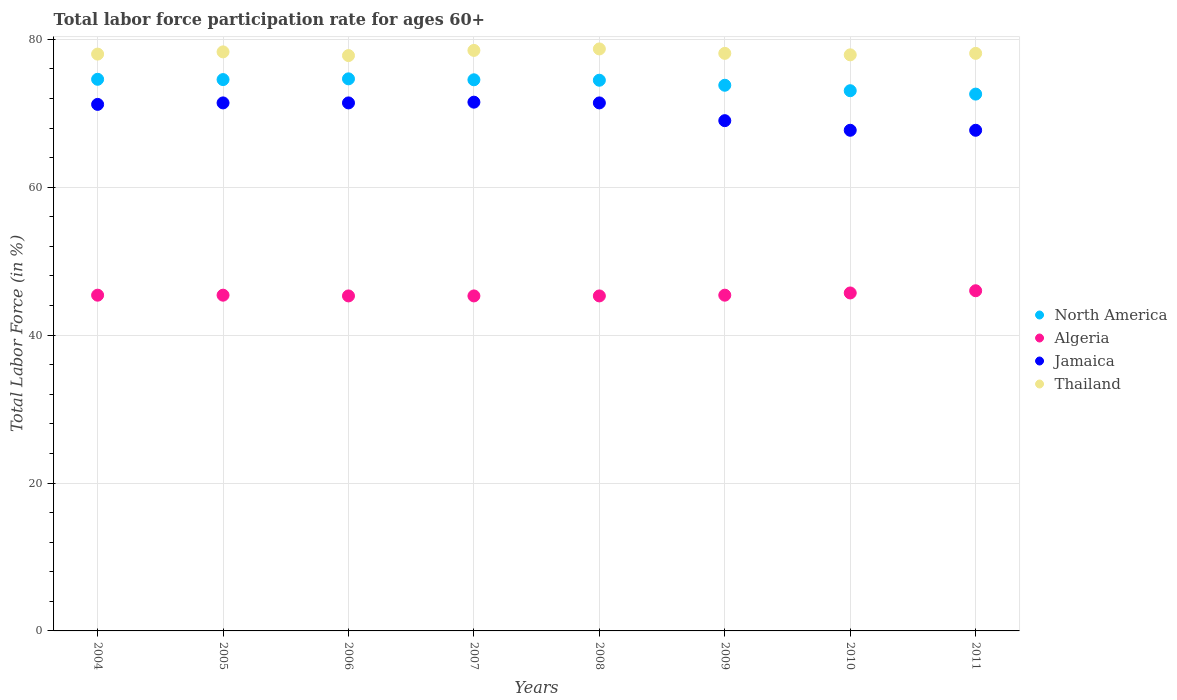What is the labor force participation rate in Algeria in 2006?
Your answer should be compact. 45.3. Across all years, what is the maximum labor force participation rate in North America?
Provide a short and direct response. 74.65. Across all years, what is the minimum labor force participation rate in Algeria?
Ensure brevity in your answer.  45.3. In which year was the labor force participation rate in North America maximum?
Provide a succinct answer. 2006. What is the total labor force participation rate in Algeria in the graph?
Ensure brevity in your answer.  363.8. What is the difference between the labor force participation rate in Thailand in 2010 and that in 2011?
Offer a terse response. -0.2. What is the difference between the labor force participation rate in Thailand in 2006 and the labor force participation rate in Algeria in 2008?
Give a very brief answer. 32.5. What is the average labor force participation rate in North America per year?
Make the answer very short. 74.03. In the year 2005, what is the difference between the labor force participation rate in North America and labor force participation rate in Thailand?
Keep it short and to the point. -3.75. In how many years, is the labor force participation rate in North America greater than 28 %?
Ensure brevity in your answer.  8. What is the ratio of the labor force participation rate in North America in 2004 to that in 2010?
Your answer should be very brief. 1.02. Is the difference between the labor force participation rate in North America in 2004 and 2010 greater than the difference between the labor force participation rate in Thailand in 2004 and 2010?
Offer a very short reply. Yes. What is the difference between the highest and the second highest labor force participation rate in North America?
Provide a short and direct response. 0.06. What is the difference between the highest and the lowest labor force participation rate in Algeria?
Provide a succinct answer. 0.7. Does the labor force participation rate in North America monotonically increase over the years?
Your response must be concise. No. Is the labor force participation rate in Jamaica strictly greater than the labor force participation rate in Algeria over the years?
Make the answer very short. Yes. How many dotlines are there?
Ensure brevity in your answer.  4. Are the values on the major ticks of Y-axis written in scientific E-notation?
Keep it short and to the point. No. What is the title of the graph?
Keep it short and to the point. Total labor force participation rate for ages 60+. Does "Germany" appear as one of the legend labels in the graph?
Offer a terse response. No. What is the Total Labor Force (in %) in North America in 2004?
Provide a short and direct response. 74.59. What is the Total Labor Force (in %) of Algeria in 2004?
Your answer should be compact. 45.4. What is the Total Labor Force (in %) of Jamaica in 2004?
Offer a very short reply. 71.2. What is the Total Labor Force (in %) in Thailand in 2004?
Ensure brevity in your answer.  78. What is the Total Labor Force (in %) in North America in 2005?
Offer a very short reply. 74.55. What is the Total Labor Force (in %) of Algeria in 2005?
Give a very brief answer. 45.4. What is the Total Labor Force (in %) of Jamaica in 2005?
Ensure brevity in your answer.  71.4. What is the Total Labor Force (in %) of Thailand in 2005?
Offer a terse response. 78.3. What is the Total Labor Force (in %) in North America in 2006?
Provide a succinct answer. 74.65. What is the Total Labor Force (in %) in Algeria in 2006?
Offer a very short reply. 45.3. What is the Total Labor Force (in %) in Jamaica in 2006?
Keep it short and to the point. 71.4. What is the Total Labor Force (in %) of Thailand in 2006?
Your answer should be compact. 77.8. What is the Total Labor Force (in %) of North America in 2007?
Provide a succinct answer. 74.53. What is the Total Labor Force (in %) in Algeria in 2007?
Provide a short and direct response. 45.3. What is the Total Labor Force (in %) in Jamaica in 2007?
Your answer should be compact. 71.5. What is the Total Labor Force (in %) of Thailand in 2007?
Keep it short and to the point. 78.5. What is the Total Labor Force (in %) of North America in 2008?
Give a very brief answer. 74.47. What is the Total Labor Force (in %) of Algeria in 2008?
Your response must be concise. 45.3. What is the Total Labor Force (in %) of Jamaica in 2008?
Make the answer very short. 71.4. What is the Total Labor Force (in %) of Thailand in 2008?
Provide a short and direct response. 78.7. What is the Total Labor Force (in %) in North America in 2009?
Ensure brevity in your answer.  73.79. What is the Total Labor Force (in %) of Algeria in 2009?
Provide a short and direct response. 45.4. What is the Total Labor Force (in %) in Thailand in 2009?
Keep it short and to the point. 78.1. What is the Total Labor Force (in %) in North America in 2010?
Your answer should be very brief. 73.05. What is the Total Labor Force (in %) of Algeria in 2010?
Offer a terse response. 45.7. What is the Total Labor Force (in %) of Jamaica in 2010?
Offer a very short reply. 67.7. What is the Total Labor Force (in %) in Thailand in 2010?
Ensure brevity in your answer.  77.9. What is the Total Labor Force (in %) of North America in 2011?
Keep it short and to the point. 72.59. What is the Total Labor Force (in %) in Jamaica in 2011?
Your response must be concise. 67.7. What is the Total Labor Force (in %) of Thailand in 2011?
Your answer should be very brief. 78.1. Across all years, what is the maximum Total Labor Force (in %) of North America?
Provide a short and direct response. 74.65. Across all years, what is the maximum Total Labor Force (in %) of Algeria?
Make the answer very short. 46. Across all years, what is the maximum Total Labor Force (in %) of Jamaica?
Keep it short and to the point. 71.5. Across all years, what is the maximum Total Labor Force (in %) in Thailand?
Your response must be concise. 78.7. Across all years, what is the minimum Total Labor Force (in %) of North America?
Keep it short and to the point. 72.59. Across all years, what is the minimum Total Labor Force (in %) in Algeria?
Give a very brief answer. 45.3. Across all years, what is the minimum Total Labor Force (in %) of Jamaica?
Offer a terse response. 67.7. Across all years, what is the minimum Total Labor Force (in %) in Thailand?
Offer a terse response. 77.8. What is the total Total Labor Force (in %) of North America in the graph?
Make the answer very short. 592.22. What is the total Total Labor Force (in %) in Algeria in the graph?
Give a very brief answer. 363.8. What is the total Total Labor Force (in %) of Jamaica in the graph?
Offer a terse response. 561.3. What is the total Total Labor Force (in %) of Thailand in the graph?
Give a very brief answer. 625.4. What is the difference between the Total Labor Force (in %) in North America in 2004 and that in 2005?
Offer a very short reply. 0.04. What is the difference between the Total Labor Force (in %) in Jamaica in 2004 and that in 2005?
Your response must be concise. -0.2. What is the difference between the Total Labor Force (in %) in North America in 2004 and that in 2006?
Provide a succinct answer. -0.06. What is the difference between the Total Labor Force (in %) in Thailand in 2004 and that in 2006?
Ensure brevity in your answer.  0.2. What is the difference between the Total Labor Force (in %) of North America in 2004 and that in 2007?
Ensure brevity in your answer.  0.07. What is the difference between the Total Labor Force (in %) of Algeria in 2004 and that in 2007?
Give a very brief answer. 0.1. What is the difference between the Total Labor Force (in %) of Jamaica in 2004 and that in 2007?
Your answer should be very brief. -0.3. What is the difference between the Total Labor Force (in %) in Thailand in 2004 and that in 2007?
Provide a short and direct response. -0.5. What is the difference between the Total Labor Force (in %) of North America in 2004 and that in 2008?
Keep it short and to the point. 0.13. What is the difference between the Total Labor Force (in %) in Jamaica in 2004 and that in 2008?
Offer a very short reply. -0.2. What is the difference between the Total Labor Force (in %) of Thailand in 2004 and that in 2008?
Your answer should be compact. -0.7. What is the difference between the Total Labor Force (in %) in North America in 2004 and that in 2009?
Offer a very short reply. 0.81. What is the difference between the Total Labor Force (in %) of North America in 2004 and that in 2010?
Offer a terse response. 1.54. What is the difference between the Total Labor Force (in %) in North America in 2004 and that in 2011?
Ensure brevity in your answer.  2. What is the difference between the Total Labor Force (in %) in Thailand in 2004 and that in 2011?
Your answer should be very brief. -0.1. What is the difference between the Total Labor Force (in %) in North America in 2005 and that in 2006?
Ensure brevity in your answer.  -0.1. What is the difference between the Total Labor Force (in %) in Jamaica in 2005 and that in 2006?
Give a very brief answer. 0. What is the difference between the Total Labor Force (in %) of Thailand in 2005 and that in 2006?
Offer a terse response. 0.5. What is the difference between the Total Labor Force (in %) of North America in 2005 and that in 2007?
Provide a short and direct response. 0.03. What is the difference between the Total Labor Force (in %) in North America in 2005 and that in 2008?
Make the answer very short. 0.09. What is the difference between the Total Labor Force (in %) in Algeria in 2005 and that in 2008?
Provide a short and direct response. 0.1. What is the difference between the Total Labor Force (in %) of North America in 2005 and that in 2009?
Provide a short and direct response. 0.77. What is the difference between the Total Labor Force (in %) of Algeria in 2005 and that in 2009?
Ensure brevity in your answer.  0. What is the difference between the Total Labor Force (in %) of Jamaica in 2005 and that in 2009?
Provide a short and direct response. 2.4. What is the difference between the Total Labor Force (in %) of North America in 2005 and that in 2010?
Offer a terse response. 1.5. What is the difference between the Total Labor Force (in %) in Jamaica in 2005 and that in 2010?
Make the answer very short. 3.7. What is the difference between the Total Labor Force (in %) in Thailand in 2005 and that in 2010?
Ensure brevity in your answer.  0.4. What is the difference between the Total Labor Force (in %) in North America in 2005 and that in 2011?
Give a very brief answer. 1.96. What is the difference between the Total Labor Force (in %) in Thailand in 2005 and that in 2011?
Your answer should be compact. 0.2. What is the difference between the Total Labor Force (in %) in North America in 2006 and that in 2007?
Your response must be concise. 0.13. What is the difference between the Total Labor Force (in %) of Algeria in 2006 and that in 2007?
Offer a very short reply. 0. What is the difference between the Total Labor Force (in %) of North America in 2006 and that in 2008?
Give a very brief answer. 0.19. What is the difference between the Total Labor Force (in %) of Algeria in 2006 and that in 2008?
Ensure brevity in your answer.  0. What is the difference between the Total Labor Force (in %) in Jamaica in 2006 and that in 2008?
Your answer should be compact. 0. What is the difference between the Total Labor Force (in %) in Thailand in 2006 and that in 2008?
Your answer should be very brief. -0.9. What is the difference between the Total Labor Force (in %) of North America in 2006 and that in 2009?
Ensure brevity in your answer.  0.87. What is the difference between the Total Labor Force (in %) of Thailand in 2006 and that in 2009?
Offer a terse response. -0.3. What is the difference between the Total Labor Force (in %) in North America in 2006 and that in 2010?
Offer a very short reply. 1.6. What is the difference between the Total Labor Force (in %) in Algeria in 2006 and that in 2010?
Your answer should be compact. -0.4. What is the difference between the Total Labor Force (in %) in Thailand in 2006 and that in 2010?
Your answer should be compact. -0.1. What is the difference between the Total Labor Force (in %) of North America in 2006 and that in 2011?
Offer a very short reply. 2.06. What is the difference between the Total Labor Force (in %) of Algeria in 2006 and that in 2011?
Make the answer very short. -0.7. What is the difference between the Total Labor Force (in %) in Jamaica in 2006 and that in 2011?
Offer a very short reply. 3.7. What is the difference between the Total Labor Force (in %) of North America in 2007 and that in 2008?
Your response must be concise. 0.06. What is the difference between the Total Labor Force (in %) in Thailand in 2007 and that in 2008?
Keep it short and to the point. -0.2. What is the difference between the Total Labor Force (in %) of North America in 2007 and that in 2009?
Make the answer very short. 0.74. What is the difference between the Total Labor Force (in %) in Algeria in 2007 and that in 2009?
Ensure brevity in your answer.  -0.1. What is the difference between the Total Labor Force (in %) in Thailand in 2007 and that in 2009?
Your answer should be very brief. 0.4. What is the difference between the Total Labor Force (in %) in North America in 2007 and that in 2010?
Offer a very short reply. 1.48. What is the difference between the Total Labor Force (in %) in Jamaica in 2007 and that in 2010?
Make the answer very short. 3.8. What is the difference between the Total Labor Force (in %) in Thailand in 2007 and that in 2010?
Give a very brief answer. 0.6. What is the difference between the Total Labor Force (in %) of North America in 2007 and that in 2011?
Your answer should be compact. 1.93. What is the difference between the Total Labor Force (in %) of Algeria in 2007 and that in 2011?
Ensure brevity in your answer.  -0.7. What is the difference between the Total Labor Force (in %) of Jamaica in 2007 and that in 2011?
Keep it short and to the point. 3.8. What is the difference between the Total Labor Force (in %) of North America in 2008 and that in 2009?
Your answer should be very brief. 0.68. What is the difference between the Total Labor Force (in %) in Algeria in 2008 and that in 2009?
Provide a short and direct response. -0.1. What is the difference between the Total Labor Force (in %) of Jamaica in 2008 and that in 2009?
Provide a short and direct response. 2.4. What is the difference between the Total Labor Force (in %) in Thailand in 2008 and that in 2009?
Your answer should be compact. 0.6. What is the difference between the Total Labor Force (in %) of North America in 2008 and that in 2010?
Your response must be concise. 1.42. What is the difference between the Total Labor Force (in %) in Jamaica in 2008 and that in 2010?
Offer a terse response. 3.7. What is the difference between the Total Labor Force (in %) of North America in 2008 and that in 2011?
Provide a succinct answer. 1.88. What is the difference between the Total Labor Force (in %) in Jamaica in 2008 and that in 2011?
Give a very brief answer. 3.7. What is the difference between the Total Labor Force (in %) in North America in 2009 and that in 2010?
Ensure brevity in your answer.  0.74. What is the difference between the Total Labor Force (in %) in Algeria in 2009 and that in 2010?
Make the answer very short. -0.3. What is the difference between the Total Labor Force (in %) of Thailand in 2009 and that in 2010?
Keep it short and to the point. 0.2. What is the difference between the Total Labor Force (in %) of North America in 2009 and that in 2011?
Provide a succinct answer. 1.2. What is the difference between the Total Labor Force (in %) of Jamaica in 2009 and that in 2011?
Make the answer very short. 1.3. What is the difference between the Total Labor Force (in %) of North America in 2010 and that in 2011?
Provide a succinct answer. 0.46. What is the difference between the Total Labor Force (in %) of Algeria in 2010 and that in 2011?
Your answer should be very brief. -0.3. What is the difference between the Total Labor Force (in %) of North America in 2004 and the Total Labor Force (in %) of Algeria in 2005?
Keep it short and to the point. 29.19. What is the difference between the Total Labor Force (in %) in North America in 2004 and the Total Labor Force (in %) in Jamaica in 2005?
Your answer should be compact. 3.19. What is the difference between the Total Labor Force (in %) in North America in 2004 and the Total Labor Force (in %) in Thailand in 2005?
Your answer should be compact. -3.71. What is the difference between the Total Labor Force (in %) of Algeria in 2004 and the Total Labor Force (in %) of Jamaica in 2005?
Provide a succinct answer. -26. What is the difference between the Total Labor Force (in %) of Algeria in 2004 and the Total Labor Force (in %) of Thailand in 2005?
Your answer should be compact. -32.9. What is the difference between the Total Labor Force (in %) in Jamaica in 2004 and the Total Labor Force (in %) in Thailand in 2005?
Give a very brief answer. -7.1. What is the difference between the Total Labor Force (in %) in North America in 2004 and the Total Labor Force (in %) in Algeria in 2006?
Your answer should be compact. 29.29. What is the difference between the Total Labor Force (in %) of North America in 2004 and the Total Labor Force (in %) of Jamaica in 2006?
Provide a succinct answer. 3.19. What is the difference between the Total Labor Force (in %) in North America in 2004 and the Total Labor Force (in %) in Thailand in 2006?
Ensure brevity in your answer.  -3.21. What is the difference between the Total Labor Force (in %) in Algeria in 2004 and the Total Labor Force (in %) in Jamaica in 2006?
Your answer should be very brief. -26. What is the difference between the Total Labor Force (in %) in Algeria in 2004 and the Total Labor Force (in %) in Thailand in 2006?
Provide a succinct answer. -32.4. What is the difference between the Total Labor Force (in %) in Jamaica in 2004 and the Total Labor Force (in %) in Thailand in 2006?
Your answer should be very brief. -6.6. What is the difference between the Total Labor Force (in %) of North America in 2004 and the Total Labor Force (in %) of Algeria in 2007?
Your answer should be compact. 29.29. What is the difference between the Total Labor Force (in %) in North America in 2004 and the Total Labor Force (in %) in Jamaica in 2007?
Provide a succinct answer. 3.09. What is the difference between the Total Labor Force (in %) in North America in 2004 and the Total Labor Force (in %) in Thailand in 2007?
Make the answer very short. -3.91. What is the difference between the Total Labor Force (in %) in Algeria in 2004 and the Total Labor Force (in %) in Jamaica in 2007?
Offer a terse response. -26.1. What is the difference between the Total Labor Force (in %) in Algeria in 2004 and the Total Labor Force (in %) in Thailand in 2007?
Your response must be concise. -33.1. What is the difference between the Total Labor Force (in %) of Jamaica in 2004 and the Total Labor Force (in %) of Thailand in 2007?
Your answer should be compact. -7.3. What is the difference between the Total Labor Force (in %) of North America in 2004 and the Total Labor Force (in %) of Algeria in 2008?
Offer a terse response. 29.29. What is the difference between the Total Labor Force (in %) in North America in 2004 and the Total Labor Force (in %) in Jamaica in 2008?
Your answer should be compact. 3.19. What is the difference between the Total Labor Force (in %) of North America in 2004 and the Total Labor Force (in %) of Thailand in 2008?
Your response must be concise. -4.11. What is the difference between the Total Labor Force (in %) in Algeria in 2004 and the Total Labor Force (in %) in Thailand in 2008?
Offer a terse response. -33.3. What is the difference between the Total Labor Force (in %) in Jamaica in 2004 and the Total Labor Force (in %) in Thailand in 2008?
Make the answer very short. -7.5. What is the difference between the Total Labor Force (in %) of North America in 2004 and the Total Labor Force (in %) of Algeria in 2009?
Give a very brief answer. 29.19. What is the difference between the Total Labor Force (in %) of North America in 2004 and the Total Labor Force (in %) of Jamaica in 2009?
Provide a succinct answer. 5.59. What is the difference between the Total Labor Force (in %) of North America in 2004 and the Total Labor Force (in %) of Thailand in 2009?
Offer a terse response. -3.51. What is the difference between the Total Labor Force (in %) of Algeria in 2004 and the Total Labor Force (in %) of Jamaica in 2009?
Keep it short and to the point. -23.6. What is the difference between the Total Labor Force (in %) of Algeria in 2004 and the Total Labor Force (in %) of Thailand in 2009?
Make the answer very short. -32.7. What is the difference between the Total Labor Force (in %) in North America in 2004 and the Total Labor Force (in %) in Algeria in 2010?
Offer a very short reply. 28.89. What is the difference between the Total Labor Force (in %) in North America in 2004 and the Total Labor Force (in %) in Jamaica in 2010?
Offer a very short reply. 6.89. What is the difference between the Total Labor Force (in %) in North America in 2004 and the Total Labor Force (in %) in Thailand in 2010?
Ensure brevity in your answer.  -3.31. What is the difference between the Total Labor Force (in %) of Algeria in 2004 and the Total Labor Force (in %) of Jamaica in 2010?
Ensure brevity in your answer.  -22.3. What is the difference between the Total Labor Force (in %) of Algeria in 2004 and the Total Labor Force (in %) of Thailand in 2010?
Offer a very short reply. -32.5. What is the difference between the Total Labor Force (in %) in Jamaica in 2004 and the Total Labor Force (in %) in Thailand in 2010?
Offer a very short reply. -6.7. What is the difference between the Total Labor Force (in %) of North America in 2004 and the Total Labor Force (in %) of Algeria in 2011?
Give a very brief answer. 28.59. What is the difference between the Total Labor Force (in %) in North America in 2004 and the Total Labor Force (in %) in Jamaica in 2011?
Your answer should be compact. 6.89. What is the difference between the Total Labor Force (in %) in North America in 2004 and the Total Labor Force (in %) in Thailand in 2011?
Provide a short and direct response. -3.51. What is the difference between the Total Labor Force (in %) of Algeria in 2004 and the Total Labor Force (in %) of Jamaica in 2011?
Your answer should be compact. -22.3. What is the difference between the Total Labor Force (in %) in Algeria in 2004 and the Total Labor Force (in %) in Thailand in 2011?
Keep it short and to the point. -32.7. What is the difference between the Total Labor Force (in %) in Jamaica in 2004 and the Total Labor Force (in %) in Thailand in 2011?
Keep it short and to the point. -6.9. What is the difference between the Total Labor Force (in %) in North America in 2005 and the Total Labor Force (in %) in Algeria in 2006?
Provide a short and direct response. 29.25. What is the difference between the Total Labor Force (in %) in North America in 2005 and the Total Labor Force (in %) in Jamaica in 2006?
Your response must be concise. 3.15. What is the difference between the Total Labor Force (in %) in North America in 2005 and the Total Labor Force (in %) in Thailand in 2006?
Make the answer very short. -3.25. What is the difference between the Total Labor Force (in %) in Algeria in 2005 and the Total Labor Force (in %) in Thailand in 2006?
Your answer should be very brief. -32.4. What is the difference between the Total Labor Force (in %) of North America in 2005 and the Total Labor Force (in %) of Algeria in 2007?
Offer a terse response. 29.25. What is the difference between the Total Labor Force (in %) of North America in 2005 and the Total Labor Force (in %) of Jamaica in 2007?
Your answer should be compact. 3.05. What is the difference between the Total Labor Force (in %) in North America in 2005 and the Total Labor Force (in %) in Thailand in 2007?
Offer a very short reply. -3.95. What is the difference between the Total Labor Force (in %) of Algeria in 2005 and the Total Labor Force (in %) of Jamaica in 2007?
Your answer should be compact. -26.1. What is the difference between the Total Labor Force (in %) in Algeria in 2005 and the Total Labor Force (in %) in Thailand in 2007?
Your answer should be very brief. -33.1. What is the difference between the Total Labor Force (in %) of Jamaica in 2005 and the Total Labor Force (in %) of Thailand in 2007?
Ensure brevity in your answer.  -7.1. What is the difference between the Total Labor Force (in %) in North America in 2005 and the Total Labor Force (in %) in Algeria in 2008?
Ensure brevity in your answer.  29.25. What is the difference between the Total Labor Force (in %) of North America in 2005 and the Total Labor Force (in %) of Jamaica in 2008?
Ensure brevity in your answer.  3.15. What is the difference between the Total Labor Force (in %) of North America in 2005 and the Total Labor Force (in %) of Thailand in 2008?
Offer a terse response. -4.15. What is the difference between the Total Labor Force (in %) in Algeria in 2005 and the Total Labor Force (in %) in Thailand in 2008?
Make the answer very short. -33.3. What is the difference between the Total Labor Force (in %) of Jamaica in 2005 and the Total Labor Force (in %) of Thailand in 2008?
Provide a short and direct response. -7.3. What is the difference between the Total Labor Force (in %) of North America in 2005 and the Total Labor Force (in %) of Algeria in 2009?
Provide a short and direct response. 29.15. What is the difference between the Total Labor Force (in %) of North America in 2005 and the Total Labor Force (in %) of Jamaica in 2009?
Give a very brief answer. 5.55. What is the difference between the Total Labor Force (in %) in North America in 2005 and the Total Labor Force (in %) in Thailand in 2009?
Your answer should be very brief. -3.55. What is the difference between the Total Labor Force (in %) of Algeria in 2005 and the Total Labor Force (in %) of Jamaica in 2009?
Ensure brevity in your answer.  -23.6. What is the difference between the Total Labor Force (in %) in Algeria in 2005 and the Total Labor Force (in %) in Thailand in 2009?
Provide a succinct answer. -32.7. What is the difference between the Total Labor Force (in %) of North America in 2005 and the Total Labor Force (in %) of Algeria in 2010?
Your response must be concise. 28.85. What is the difference between the Total Labor Force (in %) in North America in 2005 and the Total Labor Force (in %) in Jamaica in 2010?
Provide a succinct answer. 6.85. What is the difference between the Total Labor Force (in %) of North America in 2005 and the Total Labor Force (in %) of Thailand in 2010?
Provide a succinct answer. -3.35. What is the difference between the Total Labor Force (in %) in Algeria in 2005 and the Total Labor Force (in %) in Jamaica in 2010?
Keep it short and to the point. -22.3. What is the difference between the Total Labor Force (in %) in Algeria in 2005 and the Total Labor Force (in %) in Thailand in 2010?
Your response must be concise. -32.5. What is the difference between the Total Labor Force (in %) in Jamaica in 2005 and the Total Labor Force (in %) in Thailand in 2010?
Your answer should be compact. -6.5. What is the difference between the Total Labor Force (in %) of North America in 2005 and the Total Labor Force (in %) of Algeria in 2011?
Make the answer very short. 28.55. What is the difference between the Total Labor Force (in %) of North America in 2005 and the Total Labor Force (in %) of Jamaica in 2011?
Your answer should be compact. 6.85. What is the difference between the Total Labor Force (in %) in North America in 2005 and the Total Labor Force (in %) in Thailand in 2011?
Give a very brief answer. -3.55. What is the difference between the Total Labor Force (in %) of Algeria in 2005 and the Total Labor Force (in %) of Jamaica in 2011?
Your response must be concise. -22.3. What is the difference between the Total Labor Force (in %) of Algeria in 2005 and the Total Labor Force (in %) of Thailand in 2011?
Keep it short and to the point. -32.7. What is the difference between the Total Labor Force (in %) in North America in 2006 and the Total Labor Force (in %) in Algeria in 2007?
Provide a succinct answer. 29.35. What is the difference between the Total Labor Force (in %) of North America in 2006 and the Total Labor Force (in %) of Jamaica in 2007?
Offer a very short reply. 3.15. What is the difference between the Total Labor Force (in %) in North America in 2006 and the Total Labor Force (in %) in Thailand in 2007?
Your answer should be very brief. -3.85. What is the difference between the Total Labor Force (in %) in Algeria in 2006 and the Total Labor Force (in %) in Jamaica in 2007?
Keep it short and to the point. -26.2. What is the difference between the Total Labor Force (in %) of Algeria in 2006 and the Total Labor Force (in %) of Thailand in 2007?
Offer a very short reply. -33.2. What is the difference between the Total Labor Force (in %) of Jamaica in 2006 and the Total Labor Force (in %) of Thailand in 2007?
Offer a very short reply. -7.1. What is the difference between the Total Labor Force (in %) of North America in 2006 and the Total Labor Force (in %) of Algeria in 2008?
Make the answer very short. 29.35. What is the difference between the Total Labor Force (in %) in North America in 2006 and the Total Labor Force (in %) in Jamaica in 2008?
Offer a very short reply. 3.25. What is the difference between the Total Labor Force (in %) in North America in 2006 and the Total Labor Force (in %) in Thailand in 2008?
Provide a succinct answer. -4.05. What is the difference between the Total Labor Force (in %) of Algeria in 2006 and the Total Labor Force (in %) of Jamaica in 2008?
Offer a very short reply. -26.1. What is the difference between the Total Labor Force (in %) in Algeria in 2006 and the Total Labor Force (in %) in Thailand in 2008?
Make the answer very short. -33.4. What is the difference between the Total Labor Force (in %) of Jamaica in 2006 and the Total Labor Force (in %) of Thailand in 2008?
Keep it short and to the point. -7.3. What is the difference between the Total Labor Force (in %) in North America in 2006 and the Total Labor Force (in %) in Algeria in 2009?
Ensure brevity in your answer.  29.25. What is the difference between the Total Labor Force (in %) of North America in 2006 and the Total Labor Force (in %) of Jamaica in 2009?
Provide a succinct answer. 5.65. What is the difference between the Total Labor Force (in %) in North America in 2006 and the Total Labor Force (in %) in Thailand in 2009?
Give a very brief answer. -3.45. What is the difference between the Total Labor Force (in %) in Algeria in 2006 and the Total Labor Force (in %) in Jamaica in 2009?
Your response must be concise. -23.7. What is the difference between the Total Labor Force (in %) in Algeria in 2006 and the Total Labor Force (in %) in Thailand in 2009?
Make the answer very short. -32.8. What is the difference between the Total Labor Force (in %) in North America in 2006 and the Total Labor Force (in %) in Algeria in 2010?
Ensure brevity in your answer.  28.95. What is the difference between the Total Labor Force (in %) in North America in 2006 and the Total Labor Force (in %) in Jamaica in 2010?
Your answer should be compact. 6.95. What is the difference between the Total Labor Force (in %) of North America in 2006 and the Total Labor Force (in %) of Thailand in 2010?
Offer a terse response. -3.25. What is the difference between the Total Labor Force (in %) in Algeria in 2006 and the Total Labor Force (in %) in Jamaica in 2010?
Make the answer very short. -22.4. What is the difference between the Total Labor Force (in %) in Algeria in 2006 and the Total Labor Force (in %) in Thailand in 2010?
Ensure brevity in your answer.  -32.6. What is the difference between the Total Labor Force (in %) of Jamaica in 2006 and the Total Labor Force (in %) of Thailand in 2010?
Offer a terse response. -6.5. What is the difference between the Total Labor Force (in %) of North America in 2006 and the Total Labor Force (in %) of Algeria in 2011?
Your answer should be compact. 28.65. What is the difference between the Total Labor Force (in %) in North America in 2006 and the Total Labor Force (in %) in Jamaica in 2011?
Ensure brevity in your answer.  6.95. What is the difference between the Total Labor Force (in %) of North America in 2006 and the Total Labor Force (in %) of Thailand in 2011?
Make the answer very short. -3.45. What is the difference between the Total Labor Force (in %) in Algeria in 2006 and the Total Labor Force (in %) in Jamaica in 2011?
Give a very brief answer. -22.4. What is the difference between the Total Labor Force (in %) in Algeria in 2006 and the Total Labor Force (in %) in Thailand in 2011?
Your answer should be very brief. -32.8. What is the difference between the Total Labor Force (in %) of Jamaica in 2006 and the Total Labor Force (in %) of Thailand in 2011?
Your answer should be compact. -6.7. What is the difference between the Total Labor Force (in %) of North America in 2007 and the Total Labor Force (in %) of Algeria in 2008?
Your response must be concise. 29.23. What is the difference between the Total Labor Force (in %) of North America in 2007 and the Total Labor Force (in %) of Jamaica in 2008?
Offer a terse response. 3.13. What is the difference between the Total Labor Force (in %) in North America in 2007 and the Total Labor Force (in %) in Thailand in 2008?
Your answer should be compact. -4.17. What is the difference between the Total Labor Force (in %) in Algeria in 2007 and the Total Labor Force (in %) in Jamaica in 2008?
Your answer should be compact. -26.1. What is the difference between the Total Labor Force (in %) of Algeria in 2007 and the Total Labor Force (in %) of Thailand in 2008?
Make the answer very short. -33.4. What is the difference between the Total Labor Force (in %) of Jamaica in 2007 and the Total Labor Force (in %) of Thailand in 2008?
Provide a short and direct response. -7.2. What is the difference between the Total Labor Force (in %) of North America in 2007 and the Total Labor Force (in %) of Algeria in 2009?
Provide a succinct answer. 29.13. What is the difference between the Total Labor Force (in %) in North America in 2007 and the Total Labor Force (in %) in Jamaica in 2009?
Provide a succinct answer. 5.53. What is the difference between the Total Labor Force (in %) of North America in 2007 and the Total Labor Force (in %) of Thailand in 2009?
Offer a very short reply. -3.57. What is the difference between the Total Labor Force (in %) of Algeria in 2007 and the Total Labor Force (in %) of Jamaica in 2009?
Offer a terse response. -23.7. What is the difference between the Total Labor Force (in %) in Algeria in 2007 and the Total Labor Force (in %) in Thailand in 2009?
Your answer should be very brief. -32.8. What is the difference between the Total Labor Force (in %) in North America in 2007 and the Total Labor Force (in %) in Algeria in 2010?
Your answer should be compact. 28.83. What is the difference between the Total Labor Force (in %) of North America in 2007 and the Total Labor Force (in %) of Jamaica in 2010?
Make the answer very short. 6.83. What is the difference between the Total Labor Force (in %) in North America in 2007 and the Total Labor Force (in %) in Thailand in 2010?
Provide a short and direct response. -3.37. What is the difference between the Total Labor Force (in %) in Algeria in 2007 and the Total Labor Force (in %) in Jamaica in 2010?
Provide a short and direct response. -22.4. What is the difference between the Total Labor Force (in %) in Algeria in 2007 and the Total Labor Force (in %) in Thailand in 2010?
Your answer should be compact. -32.6. What is the difference between the Total Labor Force (in %) of North America in 2007 and the Total Labor Force (in %) of Algeria in 2011?
Make the answer very short. 28.53. What is the difference between the Total Labor Force (in %) of North America in 2007 and the Total Labor Force (in %) of Jamaica in 2011?
Provide a short and direct response. 6.83. What is the difference between the Total Labor Force (in %) of North America in 2007 and the Total Labor Force (in %) of Thailand in 2011?
Provide a succinct answer. -3.57. What is the difference between the Total Labor Force (in %) of Algeria in 2007 and the Total Labor Force (in %) of Jamaica in 2011?
Make the answer very short. -22.4. What is the difference between the Total Labor Force (in %) of Algeria in 2007 and the Total Labor Force (in %) of Thailand in 2011?
Make the answer very short. -32.8. What is the difference between the Total Labor Force (in %) of Jamaica in 2007 and the Total Labor Force (in %) of Thailand in 2011?
Make the answer very short. -6.6. What is the difference between the Total Labor Force (in %) of North America in 2008 and the Total Labor Force (in %) of Algeria in 2009?
Offer a terse response. 29.07. What is the difference between the Total Labor Force (in %) of North America in 2008 and the Total Labor Force (in %) of Jamaica in 2009?
Give a very brief answer. 5.47. What is the difference between the Total Labor Force (in %) in North America in 2008 and the Total Labor Force (in %) in Thailand in 2009?
Provide a succinct answer. -3.63. What is the difference between the Total Labor Force (in %) in Algeria in 2008 and the Total Labor Force (in %) in Jamaica in 2009?
Your answer should be compact. -23.7. What is the difference between the Total Labor Force (in %) of Algeria in 2008 and the Total Labor Force (in %) of Thailand in 2009?
Your answer should be very brief. -32.8. What is the difference between the Total Labor Force (in %) of Jamaica in 2008 and the Total Labor Force (in %) of Thailand in 2009?
Give a very brief answer. -6.7. What is the difference between the Total Labor Force (in %) in North America in 2008 and the Total Labor Force (in %) in Algeria in 2010?
Your response must be concise. 28.77. What is the difference between the Total Labor Force (in %) in North America in 2008 and the Total Labor Force (in %) in Jamaica in 2010?
Your answer should be very brief. 6.77. What is the difference between the Total Labor Force (in %) of North America in 2008 and the Total Labor Force (in %) of Thailand in 2010?
Your response must be concise. -3.43. What is the difference between the Total Labor Force (in %) in Algeria in 2008 and the Total Labor Force (in %) in Jamaica in 2010?
Offer a very short reply. -22.4. What is the difference between the Total Labor Force (in %) of Algeria in 2008 and the Total Labor Force (in %) of Thailand in 2010?
Provide a succinct answer. -32.6. What is the difference between the Total Labor Force (in %) of North America in 2008 and the Total Labor Force (in %) of Algeria in 2011?
Provide a succinct answer. 28.47. What is the difference between the Total Labor Force (in %) of North America in 2008 and the Total Labor Force (in %) of Jamaica in 2011?
Keep it short and to the point. 6.77. What is the difference between the Total Labor Force (in %) of North America in 2008 and the Total Labor Force (in %) of Thailand in 2011?
Give a very brief answer. -3.63. What is the difference between the Total Labor Force (in %) of Algeria in 2008 and the Total Labor Force (in %) of Jamaica in 2011?
Make the answer very short. -22.4. What is the difference between the Total Labor Force (in %) in Algeria in 2008 and the Total Labor Force (in %) in Thailand in 2011?
Provide a short and direct response. -32.8. What is the difference between the Total Labor Force (in %) of Jamaica in 2008 and the Total Labor Force (in %) of Thailand in 2011?
Ensure brevity in your answer.  -6.7. What is the difference between the Total Labor Force (in %) of North America in 2009 and the Total Labor Force (in %) of Algeria in 2010?
Provide a short and direct response. 28.09. What is the difference between the Total Labor Force (in %) of North America in 2009 and the Total Labor Force (in %) of Jamaica in 2010?
Give a very brief answer. 6.09. What is the difference between the Total Labor Force (in %) in North America in 2009 and the Total Labor Force (in %) in Thailand in 2010?
Your answer should be very brief. -4.11. What is the difference between the Total Labor Force (in %) of Algeria in 2009 and the Total Labor Force (in %) of Jamaica in 2010?
Provide a succinct answer. -22.3. What is the difference between the Total Labor Force (in %) of Algeria in 2009 and the Total Labor Force (in %) of Thailand in 2010?
Keep it short and to the point. -32.5. What is the difference between the Total Labor Force (in %) in North America in 2009 and the Total Labor Force (in %) in Algeria in 2011?
Give a very brief answer. 27.79. What is the difference between the Total Labor Force (in %) of North America in 2009 and the Total Labor Force (in %) of Jamaica in 2011?
Make the answer very short. 6.09. What is the difference between the Total Labor Force (in %) in North America in 2009 and the Total Labor Force (in %) in Thailand in 2011?
Provide a short and direct response. -4.31. What is the difference between the Total Labor Force (in %) of Algeria in 2009 and the Total Labor Force (in %) of Jamaica in 2011?
Your response must be concise. -22.3. What is the difference between the Total Labor Force (in %) of Algeria in 2009 and the Total Labor Force (in %) of Thailand in 2011?
Offer a terse response. -32.7. What is the difference between the Total Labor Force (in %) of Jamaica in 2009 and the Total Labor Force (in %) of Thailand in 2011?
Offer a very short reply. -9.1. What is the difference between the Total Labor Force (in %) in North America in 2010 and the Total Labor Force (in %) in Algeria in 2011?
Provide a succinct answer. 27.05. What is the difference between the Total Labor Force (in %) in North America in 2010 and the Total Labor Force (in %) in Jamaica in 2011?
Your answer should be compact. 5.35. What is the difference between the Total Labor Force (in %) in North America in 2010 and the Total Labor Force (in %) in Thailand in 2011?
Give a very brief answer. -5.05. What is the difference between the Total Labor Force (in %) in Algeria in 2010 and the Total Labor Force (in %) in Thailand in 2011?
Provide a succinct answer. -32.4. What is the average Total Labor Force (in %) of North America per year?
Provide a short and direct response. 74.03. What is the average Total Labor Force (in %) in Algeria per year?
Your answer should be compact. 45.48. What is the average Total Labor Force (in %) of Jamaica per year?
Provide a short and direct response. 70.16. What is the average Total Labor Force (in %) in Thailand per year?
Offer a terse response. 78.17. In the year 2004, what is the difference between the Total Labor Force (in %) in North America and Total Labor Force (in %) in Algeria?
Ensure brevity in your answer.  29.19. In the year 2004, what is the difference between the Total Labor Force (in %) in North America and Total Labor Force (in %) in Jamaica?
Your response must be concise. 3.39. In the year 2004, what is the difference between the Total Labor Force (in %) in North America and Total Labor Force (in %) in Thailand?
Offer a terse response. -3.41. In the year 2004, what is the difference between the Total Labor Force (in %) in Algeria and Total Labor Force (in %) in Jamaica?
Offer a very short reply. -25.8. In the year 2004, what is the difference between the Total Labor Force (in %) of Algeria and Total Labor Force (in %) of Thailand?
Ensure brevity in your answer.  -32.6. In the year 2004, what is the difference between the Total Labor Force (in %) in Jamaica and Total Labor Force (in %) in Thailand?
Your answer should be very brief. -6.8. In the year 2005, what is the difference between the Total Labor Force (in %) in North America and Total Labor Force (in %) in Algeria?
Offer a very short reply. 29.15. In the year 2005, what is the difference between the Total Labor Force (in %) in North America and Total Labor Force (in %) in Jamaica?
Give a very brief answer. 3.15. In the year 2005, what is the difference between the Total Labor Force (in %) in North America and Total Labor Force (in %) in Thailand?
Ensure brevity in your answer.  -3.75. In the year 2005, what is the difference between the Total Labor Force (in %) of Algeria and Total Labor Force (in %) of Thailand?
Keep it short and to the point. -32.9. In the year 2006, what is the difference between the Total Labor Force (in %) of North America and Total Labor Force (in %) of Algeria?
Ensure brevity in your answer.  29.35. In the year 2006, what is the difference between the Total Labor Force (in %) in North America and Total Labor Force (in %) in Jamaica?
Offer a very short reply. 3.25. In the year 2006, what is the difference between the Total Labor Force (in %) of North America and Total Labor Force (in %) of Thailand?
Offer a very short reply. -3.15. In the year 2006, what is the difference between the Total Labor Force (in %) of Algeria and Total Labor Force (in %) of Jamaica?
Ensure brevity in your answer.  -26.1. In the year 2006, what is the difference between the Total Labor Force (in %) of Algeria and Total Labor Force (in %) of Thailand?
Make the answer very short. -32.5. In the year 2007, what is the difference between the Total Labor Force (in %) of North America and Total Labor Force (in %) of Algeria?
Give a very brief answer. 29.23. In the year 2007, what is the difference between the Total Labor Force (in %) in North America and Total Labor Force (in %) in Jamaica?
Ensure brevity in your answer.  3.03. In the year 2007, what is the difference between the Total Labor Force (in %) of North America and Total Labor Force (in %) of Thailand?
Make the answer very short. -3.97. In the year 2007, what is the difference between the Total Labor Force (in %) of Algeria and Total Labor Force (in %) of Jamaica?
Make the answer very short. -26.2. In the year 2007, what is the difference between the Total Labor Force (in %) of Algeria and Total Labor Force (in %) of Thailand?
Give a very brief answer. -33.2. In the year 2008, what is the difference between the Total Labor Force (in %) in North America and Total Labor Force (in %) in Algeria?
Provide a succinct answer. 29.17. In the year 2008, what is the difference between the Total Labor Force (in %) of North America and Total Labor Force (in %) of Jamaica?
Your answer should be very brief. 3.07. In the year 2008, what is the difference between the Total Labor Force (in %) in North America and Total Labor Force (in %) in Thailand?
Offer a very short reply. -4.23. In the year 2008, what is the difference between the Total Labor Force (in %) of Algeria and Total Labor Force (in %) of Jamaica?
Offer a terse response. -26.1. In the year 2008, what is the difference between the Total Labor Force (in %) of Algeria and Total Labor Force (in %) of Thailand?
Keep it short and to the point. -33.4. In the year 2008, what is the difference between the Total Labor Force (in %) of Jamaica and Total Labor Force (in %) of Thailand?
Offer a terse response. -7.3. In the year 2009, what is the difference between the Total Labor Force (in %) in North America and Total Labor Force (in %) in Algeria?
Ensure brevity in your answer.  28.39. In the year 2009, what is the difference between the Total Labor Force (in %) of North America and Total Labor Force (in %) of Jamaica?
Your answer should be very brief. 4.79. In the year 2009, what is the difference between the Total Labor Force (in %) in North America and Total Labor Force (in %) in Thailand?
Provide a succinct answer. -4.31. In the year 2009, what is the difference between the Total Labor Force (in %) of Algeria and Total Labor Force (in %) of Jamaica?
Offer a terse response. -23.6. In the year 2009, what is the difference between the Total Labor Force (in %) in Algeria and Total Labor Force (in %) in Thailand?
Your answer should be compact. -32.7. In the year 2010, what is the difference between the Total Labor Force (in %) in North America and Total Labor Force (in %) in Algeria?
Your answer should be compact. 27.35. In the year 2010, what is the difference between the Total Labor Force (in %) of North America and Total Labor Force (in %) of Jamaica?
Offer a terse response. 5.35. In the year 2010, what is the difference between the Total Labor Force (in %) of North America and Total Labor Force (in %) of Thailand?
Your response must be concise. -4.85. In the year 2010, what is the difference between the Total Labor Force (in %) of Algeria and Total Labor Force (in %) of Jamaica?
Provide a succinct answer. -22. In the year 2010, what is the difference between the Total Labor Force (in %) in Algeria and Total Labor Force (in %) in Thailand?
Keep it short and to the point. -32.2. In the year 2011, what is the difference between the Total Labor Force (in %) in North America and Total Labor Force (in %) in Algeria?
Offer a terse response. 26.59. In the year 2011, what is the difference between the Total Labor Force (in %) of North America and Total Labor Force (in %) of Jamaica?
Your answer should be compact. 4.89. In the year 2011, what is the difference between the Total Labor Force (in %) in North America and Total Labor Force (in %) in Thailand?
Your answer should be compact. -5.51. In the year 2011, what is the difference between the Total Labor Force (in %) in Algeria and Total Labor Force (in %) in Jamaica?
Your answer should be compact. -21.7. In the year 2011, what is the difference between the Total Labor Force (in %) of Algeria and Total Labor Force (in %) of Thailand?
Offer a very short reply. -32.1. In the year 2011, what is the difference between the Total Labor Force (in %) of Jamaica and Total Labor Force (in %) of Thailand?
Your answer should be very brief. -10.4. What is the ratio of the Total Labor Force (in %) in North America in 2004 to that in 2005?
Your answer should be very brief. 1. What is the ratio of the Total Labor Force (in %) of Jamaica in 2004 to that in 2005?
Give a very brief answer. 1. What is the ratio of the Total Labor Force (in %) of North America in 2004 to that in 2006?
Provide a succinct answer. 1. What is the ratio of the Total Labor Force (in %) in Thailand in 2004 to that in 2006?
Provide a short and direct response. 1. What is the ratio of the Total Labor Force (in %) in Thailand in 2004 to that in 2007?
Your response must be concise. 0.99. What is the ratio of the Total Labor Force (in %) in North America in 2004 to that in 2008?
Offer a terse response. 1. What is the ratio of the Total Labor Force (in %) of Algeria in 2004 to that in 2008?
Offer a terse response. 1. What is the ratio of the Total Labor Force (in %) in Thailand in 2004 to that in 2008?
Provide a succinct answer. 0.99. What is the ratio of the Total Labor Force (in %) of North America in 2004 to that in 2009?
Offer a very short reply. 1.01. What is the ratio of the Total Labor Force (in %) of Algeria in 2004 to that in 2009?
Provide a succinct answer. 1. What is the ratio of the Total Labor Force (in %) of Jamaica in 2004 to that in 2009?
Ensure brevity in your answer.  1.03. What is the ratio of the Total Labor Force (in %) in Thailand in 2004 to that in 2009?
Make the answer very short. 1. What is the ratio of the Total Labor Force (in %) of North America in 2004 to that in 2010?
Give a very brief answer. 1.02. What is the ratio of the Total Labor Force (in %) of Jamaica in 2004 to that in 2010?
Keep it short and to the point. 1.05. What is the ratio of the Total Labor Force (in %) of Thailand in 2004 to that in 2010?
Give a very brief answer. 1. What is the ratio of the Total Labor Force (in %) in North America in 2004 to that in 2011?
Provide a short and direct response. 1.03. What is the ratio of the Total Labor Force (in %) of Jamaica in 2004 to that in 2011?
Make the answer very short. 1.05. What is the ratio of the Total Labor Force (in %) of Thailand in 2004 to that in 2011?
Offer a very short reply. 1. What is the ratio of the Total Labor Force (in %) in North America in 2005 to that in 2006?
Make the answer very short. 1. What is the ratio of the Total Labor Force (in %) of Algeria in 2005 to that in 2006?
Offer a terse response. 1. What is the ratio of the Total Labor Force (in %) of Jamaica in 2005 to that in 2006?
Give a very brief answer. 1. What is the ratio of the Total Labor Force (in %) in Thailand in 2005 to that in 2006?
Ensure brevity in your answer.  1.01. What is the ratio of the Total Labor Force (in %) in North America in 2005 to that in 2007?
Your answer should be very brief. 1. What is the ratio of the Total Labor Force (in %) of Jamaica in 2005 to that in 2007?
Your response must be concise. 1. What is the ratio of the Total Labor Force (in %) of Thailand in 2005 to that in 2007?
Make the answer very short. 1. What is the ratio of the Total Labor Force (in %) in North America in 2005 to that in 2008?
Your response must be concise. 1. What is the ratio of the Total Labor Force (in %) of Algeria in 2005 to that in 2008?
Ensure brevity in your answer.  1. What is the ratio of the Total Labor Force (in %) of Jamaica in 2005 to that in 2008?
Your answer should be compact. 1. What is the ratio of the Total Labor Force (in %) of North America in 2005 to that in 2009?
Give a very brief answer. 1.01. What is the ratio of the Total Labor Force (in %) of Algeria in 2005 to that in 2009?
Give a very brief answer. 1. What is the ratio of the Total Labor Force (in %) of Jamaica in 2005 to that in 2009?
Keep it short and to the point. 1.03. What is the ratio of the Total Labor Force (in %) of Thailand in 2005 to that in 2009?
Your answer should be very brief. 1. What is the ratio of the Total Labor Force (in %) of North America in 2005 to that in 2010?
Offer a very short reply. 1.02. What is the ratio of the Total Labor Force (in %) in Algeria in 2005 to that in 2010?
Give a very brief answer. 0.99. What is the ratio of the Total Labor Force (in %) in Jamaica in 2005 to that in 2010?
Provide a short and direct response. 1.05. What is the ratio of the Total Labor Force (in %) in Algeria in 2005 to that in 2011?
Give a very brief answer. 0.99. What is the ratio of the Total Labor Force (in %) of Jamaica in 2005 to that in 2011?
Give a very brief answer. 1.05. What is the ratio of the Total Labor Force (in %) of Thailand in 2005 to that in 2011?
Your response must be concise. 1. What is the ratio of the Total Labor Force (in %) of Jamaica in 2006 to that in 2007?
Give a very brief answer. 1. What is the ratio of the Total Labor Force (in %) of Thailand in 2006 to that in 2007?
Provide a succinct answer. 0.99. What is the ratio of the Total Labor Force (in %) of North America in 2006 to that in 2008?
Offer a very short reply. 1. What is the ratio of the Total Labor Force (in %) in Jamaica in 2006 to that in 2008?
Offer a very short reply. 1. What is the ratio of the Total Labor Force (in %) in Thailand in 2006 to that in 2008?
Offer a terse response. 0.99. What is the ratio of the Total Labor Force (in %) in North America in 2006 to that in 2009?
Your answer should be very brief. 1.01. What is the ratio of the Total Labor Force (in %) in Algeria in 2006 to that in 2009?
Offer a terse response. 1. What is the ratio of the Total Labor Force (in %) of Jamaica in 2006 to that in 2009?
Make the answer very short. 1.03. What is the ratio of the Total Labor Force (in %) of Algeria in 2006 to that in 2010?
Offer a very short reply. 0.99. What is the ratio of the Total Labor Force (in %) in Jamaica in 2006 to that in 2010?
Ensure brevity in your answer.  1.05. What is the ratio of the Total Labor Force (in %) of Thailand in 2006 to that in 2010?
Offer a terse response. 1. What is the ratio of the Total Labor Force (in %) in North America in 2006 to that in 2011?
Provide a succinct answer. 1.03. What is the ratio of the Total Labor Force (in %) in Algeria in 2006 to that in 2011?
Ensure brevity in your answer.  0.98. What is the ratio of the Total Labor Force (in %) in Jamaica in 2006 to that in 2011?
Give a very brief answer. 1.05. What is the ratio of the Total Labor Force (in %) in Thailand in 2006 to that in 2011?
Your answer should be very brief. 1. What is the ratio of the Total Labor Force (in %) of Jamaica in 2007 to that in 2008?
Ensure brevity in your answer.  1. What is the ratio of the Total Labor Force (in %) in Thailand in 2007 to that in 2008?
Make the answer very short. 1. What is the ratio of the Total Labor Force (in %) in Algeria in 2007 to that in 2009?
Make the answer very short. 1. What is the ratio of the Total Labor Force (in %) in Jamaica in 2007 to that in 2009?
Your answer should be compact. 1.04. What is the ratio of the Total Labor Force (in %) of Thailand in 2007 to that in 2009?
Make the answer very short. 1.01. What is the ratio of the Total Labor Force (in %) in North America in 2007 to that in 2010?
Your answer should be very brief. 1.02. What is the ratio of the Total Labor Force (in %) of Algeria in 2007 to that in 2010?
Offer a very short reply. 0.99. What is the ratio of the Total Labor Force (in %) of Jamaica in 2007 to that in 2010?
Your response must be concise. 1.06. What is the ratio of the Total Labor Force (in %) in Thailand in 2007 to that in 2010?
Provide a succinct answer. 1.01. What is the ratio of the Total Labor Force (in %) of North America in 2007 to that in 2011?
Ensure brevity in your answer.  1.03. What is the ratio of the Total Labor Force (in %) of Jamaica in 2007 to that in 2011?
Offer a terse response. 1.06. What is the ratio of the Total Labor Force (in %) in North America in 2008 to that in 2009?
Your answer should be compact. 1.01. What is the ratio of the Total Labor Force (in %) in Algeria in 2008 to that in 2009?
Offer a very short reply. 1. What is the ratio of the Total Labor Force (in %) of Jamaica in 2008 to that in 2009?
Give a very brief answer. 1.03. What is the ratio of the Total Labor Force (in %) of Thailand in 2008 to that in 2009?
Give a very brief answer. 1.01. What is the ratio of the Total Labor Force (in %) of North America in 2008 to that in 2010?
Give a very brief answer. 1.02. What is the ratio of the Total Labor Force (in %) in Jamaica in 2008 to that in 2010?
Offer a very short reply. 1.05. What is the ratio of the Total Labor Force (in %) of Thailand in 2008 to that in 2010?
Keep it short and to the point. 1.01. What is the ratio of the Total Labor Force (in %) of North America in 2008 to that in 2011?
Your answer should be compact. 1.03. What is the ratio of the Total Labor Force (in %) of Algeria in 2008 to that in 2011?
Provide a short and direct response. 0.98. What is the ratio of the Total Labor Force (in %) of Jamaica in 2008 to that in 2011?
Your answer should be very brief. 1.05. What is the ratio of the Total Labor Force (in %) of Thailand in 2008 to that in 2011?
Give a very brief answer. 1.01. What is the ratio of the Total Labor Force (in %) in North America in 2009 to that in 2010?
Provide a succinct answer. 1.01. What is the ratio of the Total Labor Force (in %) in Algeria in 2009 to that in 2010?
Provide a short and direct response. 0.99. What is the ratio of the Total Labor Force (in %) in Jamaica in 2009 to that in 2010?
Offer a very short reply. 1.02. What is the ratio of the Total Labor Force (in %) in Thailand in 2009 to that in 2010?
Provide a succinct answer. 1. What is the ratio of the Total Labor Force (in %) in North America in 2009 to that in 2011?
Your answer should be very brief. 1.02. What is the ratio of the Total Labor Force (in %) of Algeria in 2009 to that in 2011?
Offer a very short reply. 0.99. What is the ratio of the Total Labor Force (in %) in Jamaica in 2009 to that in 2011?
Provide a succinct answer. 1.02. What is the ratio of the Total Labor Force (in %) in Thailand in 2009 to that in 2011?
Ensure brevity in your answer.  1. What is the ratio of the Total Labor Force (in %) in North America in 2010 to that in 2011?
Provide a succinct answer. 1.01. What is the ratio of the Total Labor Force (in %) of Thailand in 2010 to that in 2011?
Your response must be concise. 1. What is the difference between the highest and the second highest Total Labor Force (in %) in North America?
Ensure brevity in your answer.  0.06. What is the difference between the highest and the second highest Total Labor Force (in %) of Jamaica?
Make the answer very short. 0.1. What is the difference between the highest and the lowest Total Labor Force (in %) in North America?
Keep it short and to the point. 2.06. What is the difference between the highest and the lowest Total Labor Force (in %) of Algeria?
Offer a very short reply. 0.7. What is the difference between the highest and the lowest Total Labor Force (in %) in Thailand?
Offer a very short reply. 0.9. 